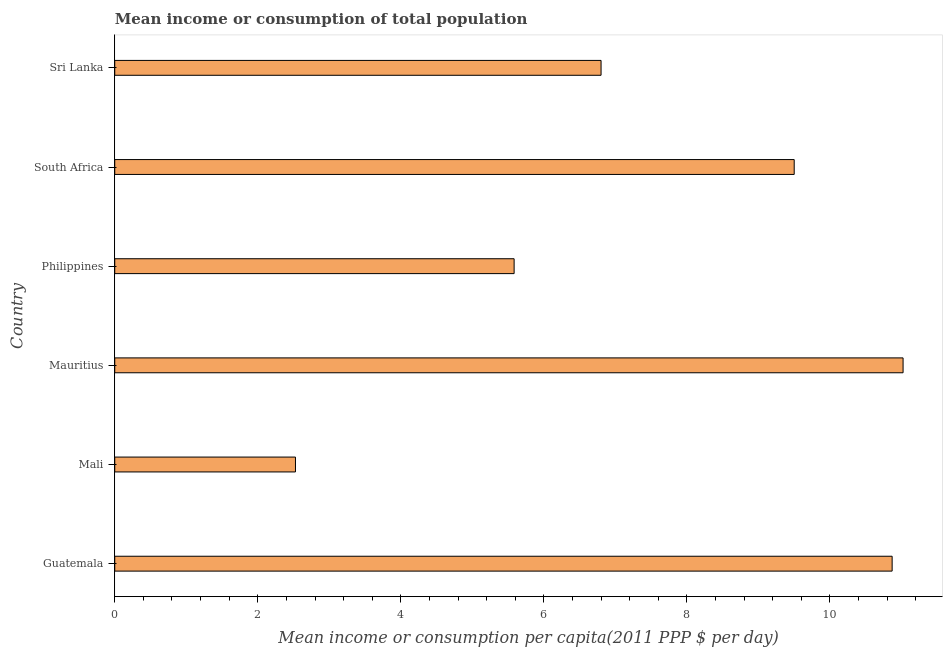Does the graph contain any zero values?
Your answer should be very brief. No. What is the title of the graph?
Your answer should be very brief. Mean income or consumption of total population. What is the label or title of the X-axis?
Ensure brevity in your answer.  Mean income or consumption per capita(2011 PPP $ per day). What is the label or title of the Y-axis?
Make the answer very short. Country. What is the mean income or consumption in Philippines?
Make the answer very short. 5.58. Across all countries, what is the maximum mean income or consumption?
Give a very brief answer. 11.02. Across all countries, what is the minimum mean income or consumption?
Offer a terse response. 2.53. In which country was the mean income or consumption maximum?
Provide a succinct answer. Mauritius. In which country was the mean income or consumption minimum?
Provide a short and direct response. Mali. What is the sum of the mean income or consumption?
Give a very brief answer. 46.3. What is the difference between the mean income or consumption in Mali and Philippines?
Your response must be concise. -3.06. What is the average mean income or consumption per country?
Your answer should be compact. 7.72. What is the median mean income or consumption?
Your answer should be compact. 8.15. What is the ratio of the mean income or consumption in Guatemala to that in Philippines?
Your answer should be compact. 1.95. What is the difference between the highest and the second highest mean income or consumption?
Make the answer very short. 0.15. How many bars are there?
Your response must be concise. 6. Are all the bars in the graph horizontal?
Your answer should be very brief. Yes. How many countries are there in the graph?
Provide a short and direct response. 6. Are the values on the major ticks of X-axis written in scientific E-notation?
Provide a succinct answer. No. What is the Mean income or consumption per capita(2011 PPP $ per day) of Guatemala?
Offer a very short reply. 10.87. What is the Mean income or consumption per capita(2011 PPP $ per day) in Mali?
Offer a terse response. 2.53. What is the Mean income or consumption per capita(2011 PPP $ per day) of Mauritius?
Offer a terse response. 11.02. What is the Mean income or consumption per capita(2011 PPP $ per day) of Philippines?
Provide a short and direct response. 5.58. What is the Mean income or consumption per capita(2011 PPP $ per day) of South Africa?
Offer a very short reply. 9.5. What is the Mean income or consumption per capita(2011 PPP $ per day) of Sri Lanka?
Your answer should be compact. 6.8. What is the difference between the Mean income or consumption per capita(2011 PPP $ per day) in Guatemala and Mali?
Provide a succinct answer. 8.34. What is the difference between the Mean income or consumption per capita(2011 PPP $ per day) in Guatemala and Mauritius?
Make the answer very short. -0.15. What is the difference between the Mean income or consumption per capita(2011 PPP $ per day) in Guatemala and Philippines?
Your response must be concise. 5.29. What is the difference between the Mean income or consumption per capita(2011 PPP $ per day) in Guatemala and South Africa?
Your response must be concise. 1.37. What is the difference between the Mean income or consumption per capita(2011 PPP $ per day) in Guatemala and Sri Lanka?
Your response must be concise. 4.07. What is the difference between the Mean income or consumption per capita(2011 PPP $ per day) in Mali and Mauritius?
Ensure brevity in your answer.  -8.5. What is the difference between the Mean income or consumption per capita(2011 PPP $ per day) in Mali and Philippines?
Offer a very short reply. -3.06. What is the difference between the Mean income or consumption per capita(2011 PPP $ per day) in Mali and South Africa?
Your answer should be very brief. -6.97. What is the difference between the Mean income or consumption per capita(2011 PPP $ per day) in Mali and Sri Lanka?
Provide a short and direct response. -4.27. What is the difference between the Mean income or consumption per capita(2011 PPP $ per day) in Mauritius and Philippines?
Your answer should be compact. 5.44. What is the difference between the Mean income or consumption per capita(2011 PPP $ per day) in Mauritius and South Africa?
Offer a terse response. 1.52. What is the difference between the Mean income or consumption per capita(2011 PPP $ per day) in Mauritius and Sri Lanka?
Make the answer very short. 4.22. What is the difference between the Mean income or consumption per capita(2011 PPP $ per day) in Philippines and South Africa?
Provide a short and direct response. -3.92. What is the difference between the Mean income or consumption per capita(2011 PPP $ per day) in Philippines and Sri Lanka?
Make the answer very short. -1.22. What is the difference between the Mean income or consumption per capita(2011 PPP $ per day) in South Africa and Sri Lanka?
Your answer should be very brief. 2.7. What is the ratio of the Mean income or consumption per capita(2011 PPP $ per day) in Guatemala to that in Mali?
Your response must be concise. 4.3. What is the ratio of the Mean income or consumption per capita(2011 PPP $ per day) in Guatemala to that in Mauritius?
Provide a succinct answer. 0.99. What is the ratio of the Mean income or consumption per capita(2011 PPP $ per day) in Guatemala to that in Philippines?
Make the answer very short. 1.95. What is the ratio of the Mean income or consumption per capita(2011 PPP $ per day) in Guatemala to that in South Africa?
Your answer should be compact. 1.14. What is the ratio of the Mean income or consumption per capita(2011 PPP $ per day) in Guatemala to that in Sri Lanka?
Offer a very short reply. 1.6. What is the ratio of the Mean income or consumption per capita(2011 PPP $ per day) in Mali to that in Mauritius?
Your response must be concise. 0.23. What is the ratio of the Mean income or consumption per capita(2011 PPP $ per day) in Mali to that in Philippines?
Make the answer very short. 0.45. What is the ratio of the Mean income or consumption per capita(2011 PPP $ per day) in Mali to that in South Africa?
Make the answer very short. 0.27. What is the ratio of the Mean income or consumption per capita(2011 PPP $ per day) in Mali to that in Sri Lanka?
Offer a very short reply. 0.37. What is the ratio of the Mean income or consumption per capita(2011 PPP $ per day) in Mauritius to that in Philippines?
Provide a short and direct response. 1.97. What is the ratio of the Mean income or consumption per capita(2011 PPP $ per day) in Mauritius to that in South Africa?
Your answer should be very brief. 1.16. What is the ratio of the Mean income or consumption per capita(2011 PPP $ per day) in Mauritius to that in Sri Lanka?
Make the answer very short. 1.62. What is the ratio of the Mean income or consumption per capita(2011 PPP $ per day) in Philippines to that in South Africa?
Provide a short and direct response. 0.59. What is the ratio of the Mean income or consumption per capita(2011 PPP $ per day) in Philippines to that in Sri Lanka?
Your answer should be very brief. 0.82. What is the ratio of the Mean income or consumption per capita(2011 PPP $ per day) in South Africa to that in Sri Lanka?
Your answer should be compact. 1.4. 